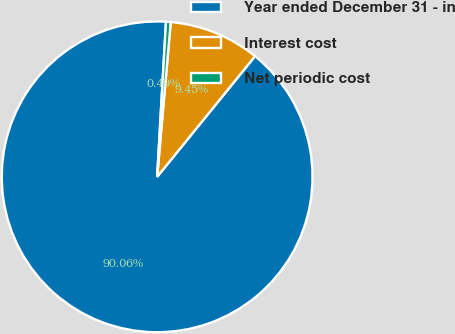Convert chart. <chart><loc_0><loc_0><loc_500><loc_500><pie_chart><fcel>Year ended December 31 - in<fcel>Interest cost<fcel>Net periodic cost<nl><fcel>90.06%<fcel>9.45%<fcel>0.49%<nl></chart> 